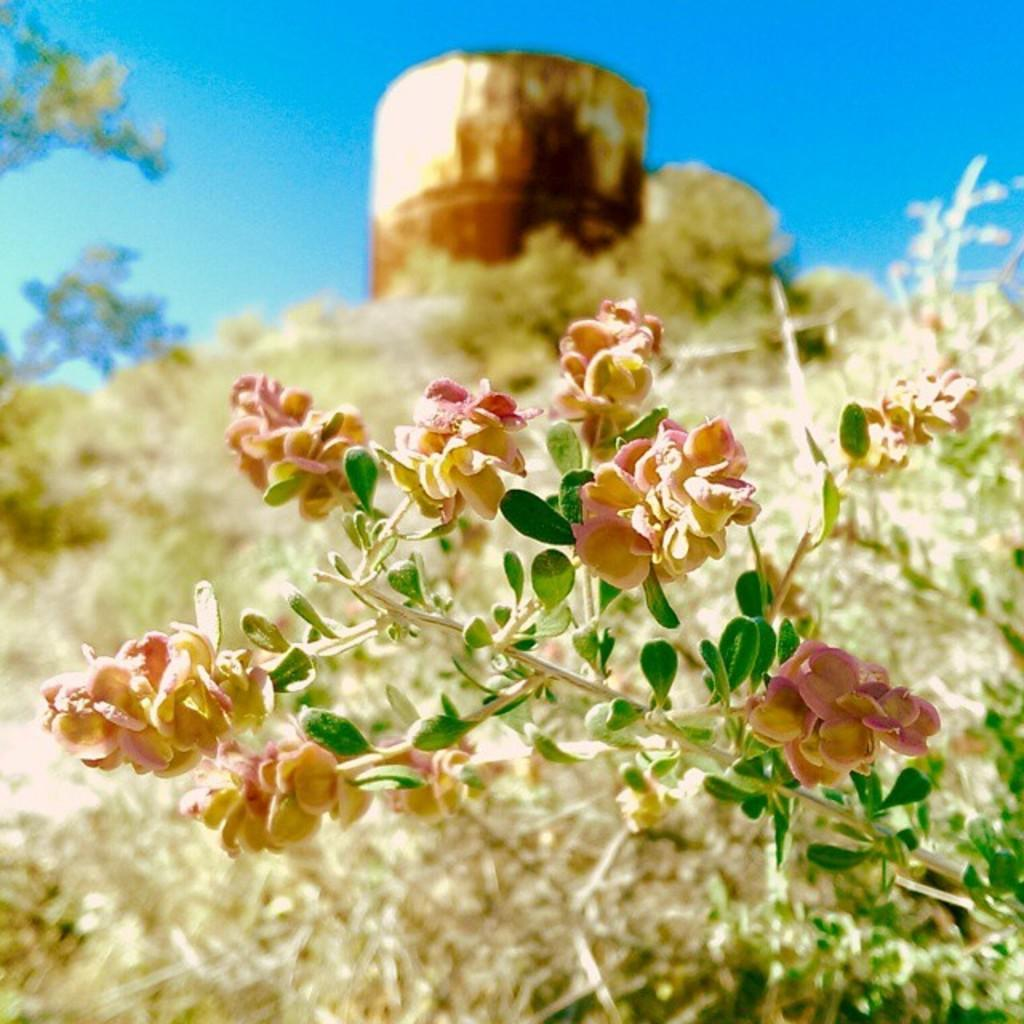What type of plant is in the image? There is a plant in the image, but the specific type cannot be determined from the provided facts. What else can be seen in the image besides the plant? There are flowers in the image. How would you describe the background of the image? The background of the image is blurred. What natural elements can be seen in the background? Trees and the sky are visible in the background. Can you describe the unspecified object in the background? Unfortunately, the facts do not provide enough information to describe the unspecified object in the background. How does the wind affect the plant in the image? There is no indication of wind in the image, so its effect on the plant cannot be determined. What type of property is visible in the image? There is no property visible in the image; it primarily features a plant, flowers, and a blurred background. 